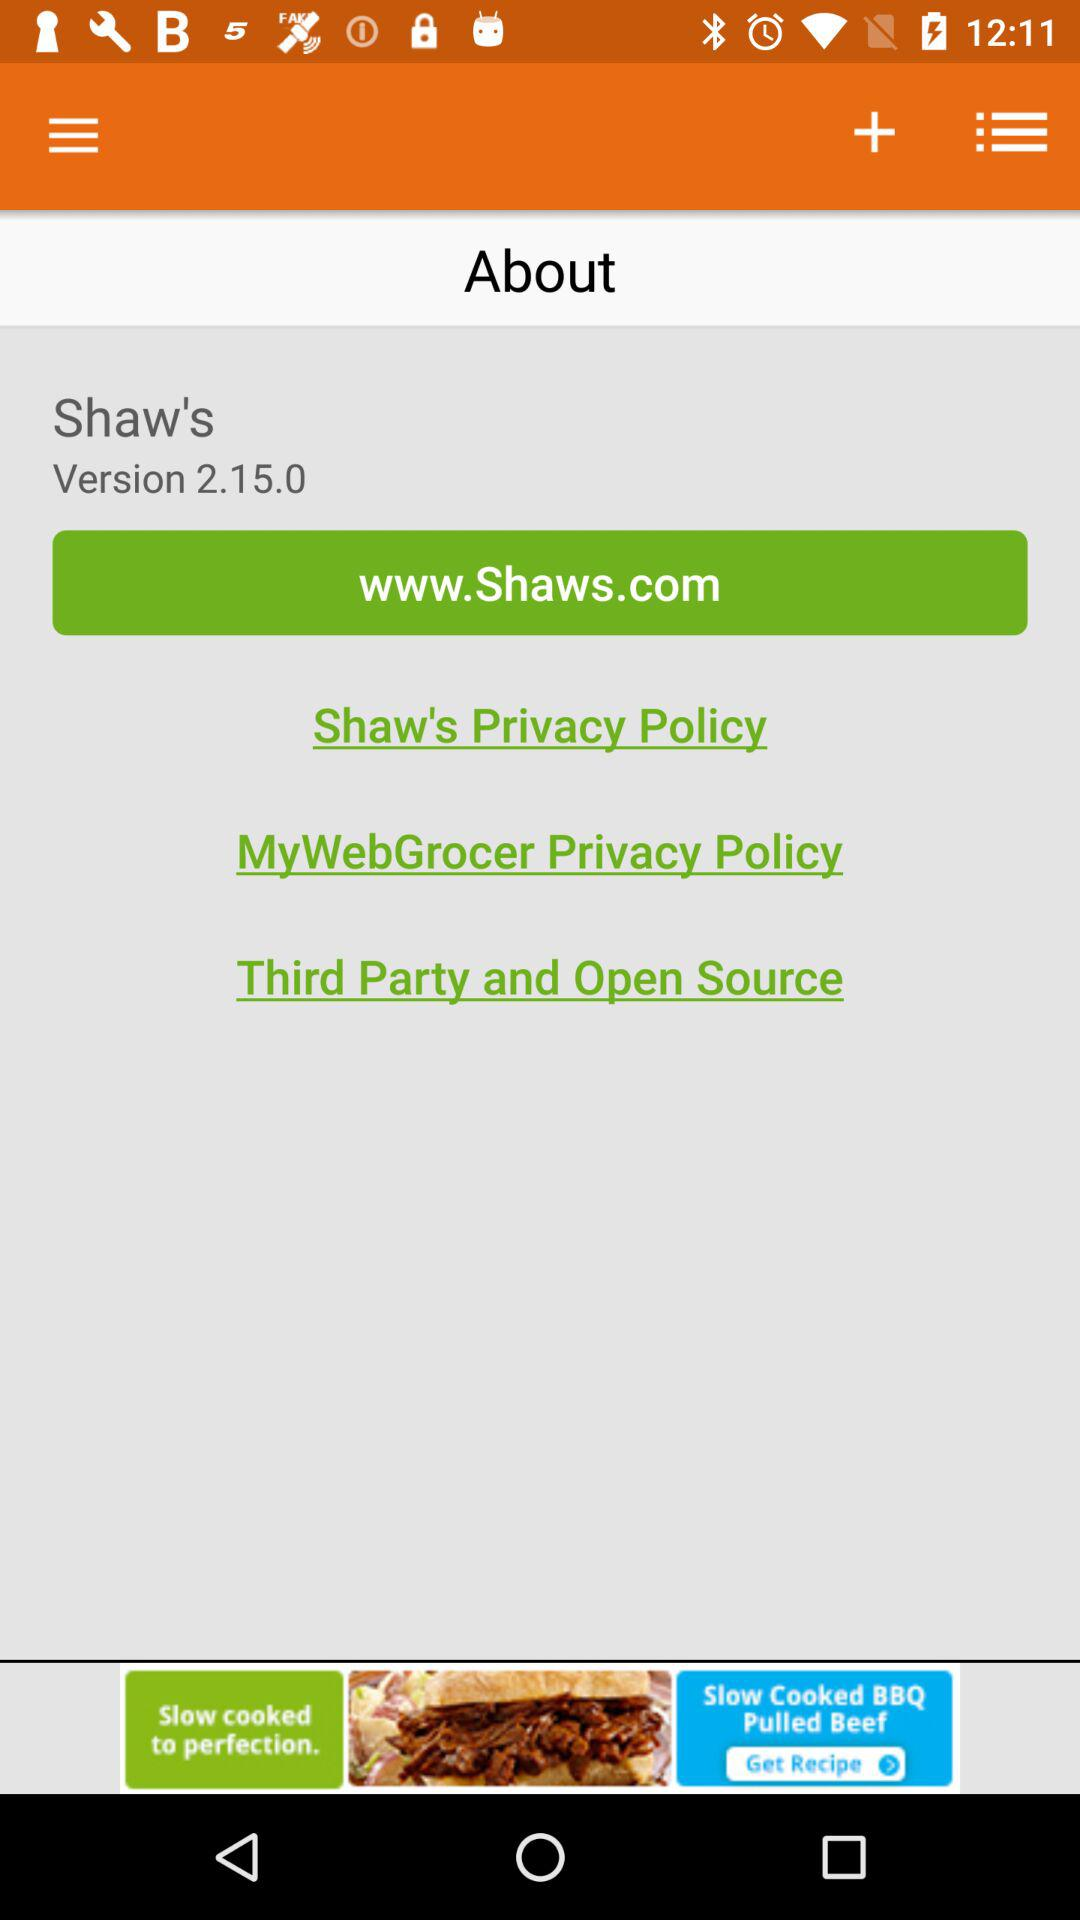What's the URL for the website? The URL is "www.Shaws.com". 